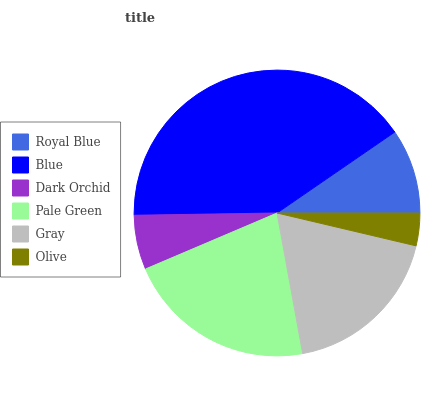Is Olive the minimum?
Answer yes or no. Yes. Is Blue the maximum?
Answer yes or no. Yes. Is Dark Orchid the minimum?
Answer yes or no. No. Is Dark Orchid the maximum?
Answer yes or no. No. Is Blue greater than Dark Orchid?
Answer yes or no. Yes. Is Dark Orchid less than Blue?
Answer yes or no. Yes. Is Dark Orchid greater than Blue?
Answer yes or no. No. Is Blue less than Dark Orchid?
Answer yes or no. No. Is Gray the high median?
Answer yes or no. Yes. Is Royal Blue the low median?
Answer yes or no. Yes. Is Pale Green the high median?
Answer yes or no. No. Is Olive the low median?
Answer yes or no. No. 